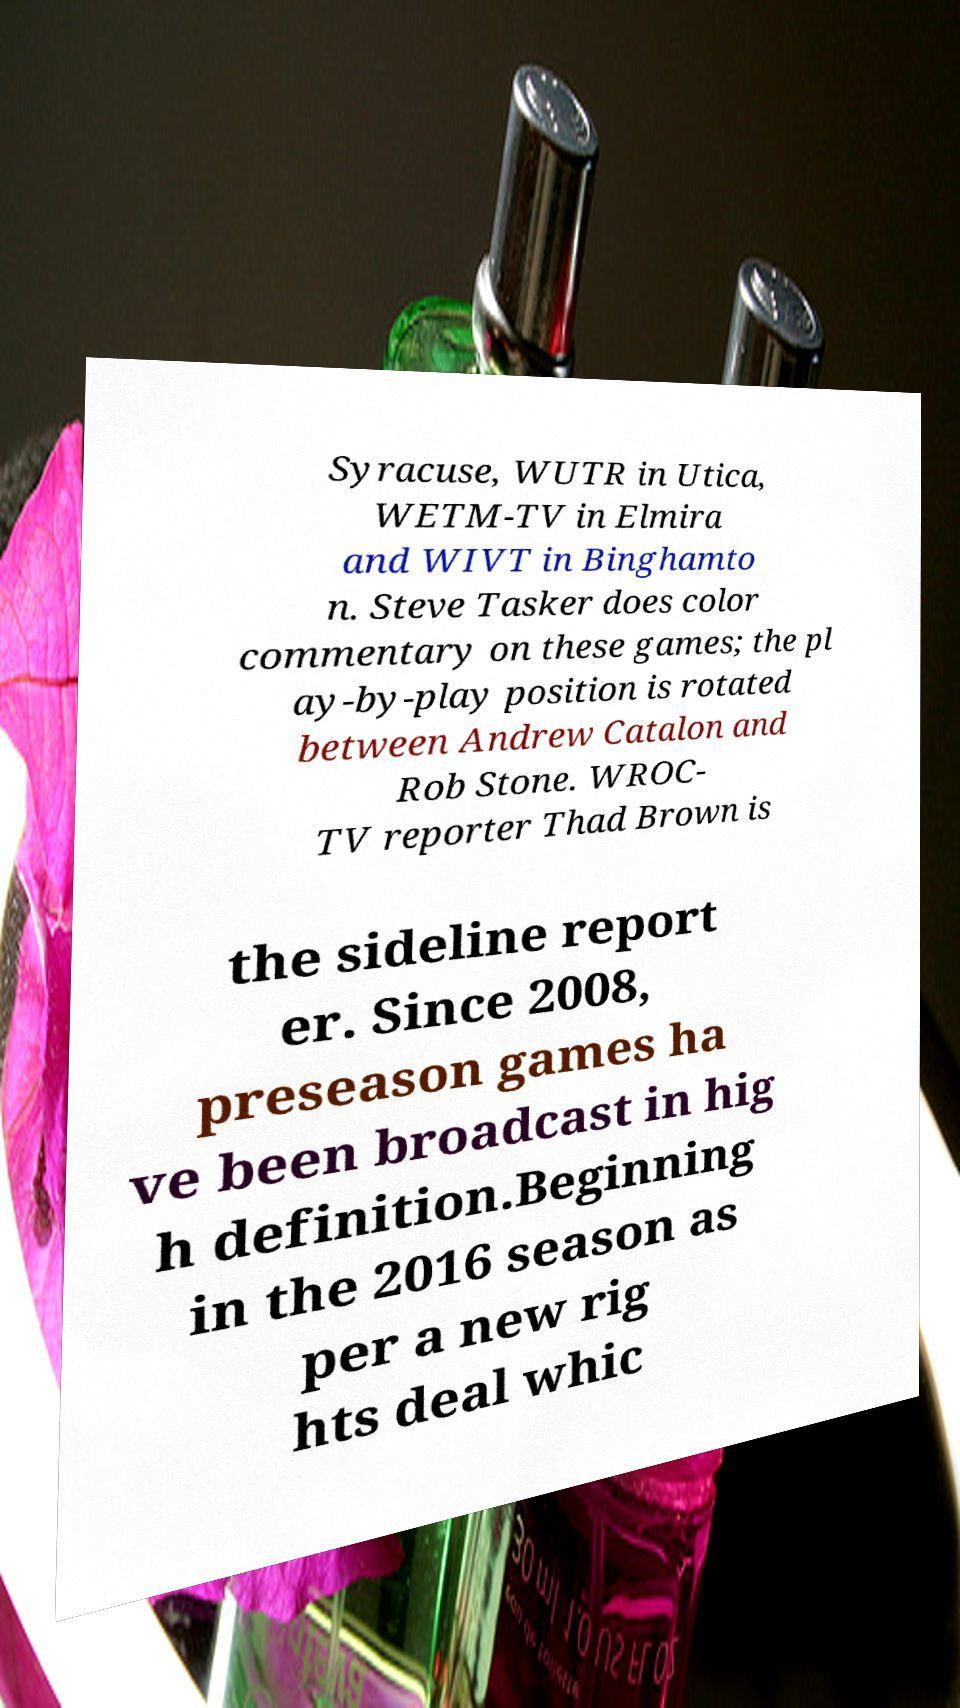Please read and relay the text visible in this image. What does it say? Syracuse, WUTR in Utica, WETM-TV in Elmira and WIVT in Binghamto n. Steve Tasker does color commentary on these games; the pl ay-by-play position is rotated between Andrew Catalon and Rob Stone. WROC- TV reporter Thad Brown is the sideline report er. Since 2008, preseason games ha ve been broadcast in hig h definition.Beginning in the 2016 season as per a new rig hts deal whic 